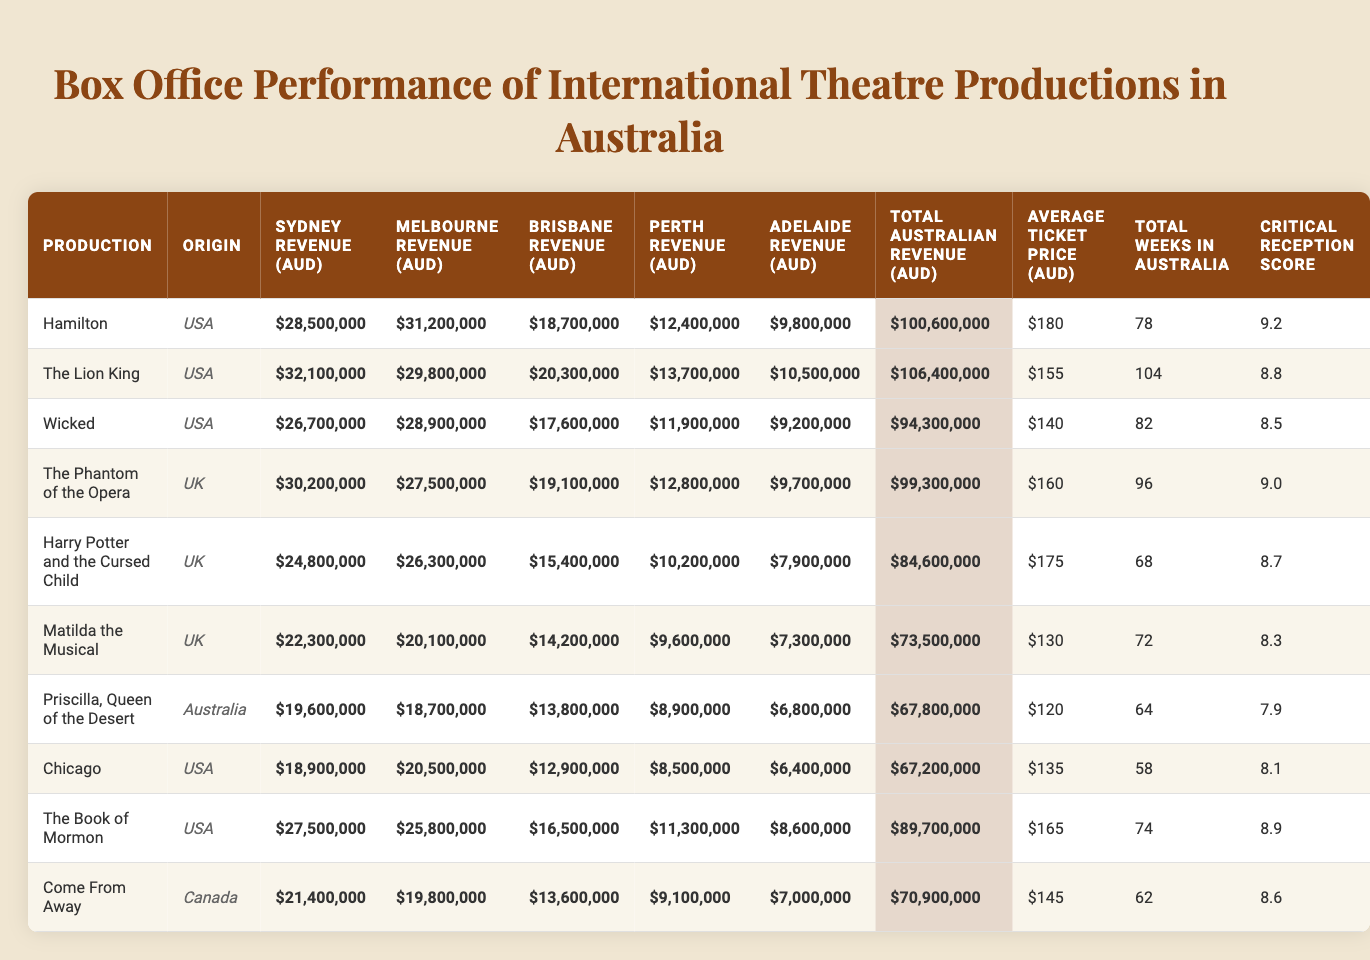What is the total revenue from the production "Hamilton" in Australia? The table shows the total Australian revenue for "Hamilton" as $100,600,000, which is provided in the "Total Australian Revenue (AUD)" column.
Answer: $100,600,000 Which production has the highest Sydney revenue? Looking at the "Sydney Revenue (AUD)" column, "The Lion King" has the highest revenue at $32,100,000.
Answer: The Lion King What is the average ticket price for "Matilda the Musical"? From the "Average Ticket Price (AUD)" column, the ticket price for "Matilda the Musical" is $130.
Answer: $130 How much more revenue did "Wicked" generate in Melbourne than in Adelaide? Calculating the difference, "Wicked" earned $28,900,000 in Melbourne and $9,200,000 in Adelaide. The difference is $28,900,000 - $9,200,000 = $19,700,000.
Answer: $19,700,000 Which production had the lowest Brisbane revenue? The "Brisbane Revenue (AUD)" column shows that "Priscilla, Queen of the Desert" had the lowest revenue at $13,800,000.
Answer: Priscilla, Queen of the Desert What is the total revenue for all productions in Perth? Adding all the values in the "Perth Revenue (AUD)" column: 12,400,000 + 13,700,000 + 11,900,000 + 12,800,000 + 10,200,000 + 9,600,000 + 8,900,000 + 8,500,000 + 11,300,000 + 9,100,000 gives a total of $110,000,000.
Answer: $110,000,000 Did "Come From Away" earn more in Brisbane or Adelaide? "Come From Away" earned $13,600,000 in Brisbane and $7,000,000 in Adelaide. Since $13,600,000 > $7,000,000, it earned more in Brisbane.
Answer: Yes What percentage of the total Australian revenue did "The Phantom of the Opera" contribute? "The Phantom of the Opera" generated $99,300,000 of the total $846,000,000. The percentage is calculated as ($99,300,000 / $846,000,000) * 100 = approximately 11.7%.
Answer: 11.7% Which production had the highest critical reception and what was the score? The production with the highest critical reception score is "Hamilton," which received a score of 9.2, found in the "Critical Reception Score" column.
Answer: Hamilton, 9.2 What was the total revenue generated by all productions from Sydney? To find this, sum the values from the "Sydney Revenue (AUD)" column: 28,500,000 + 32,100,000 + 26,700,000 + 30,200,000 + 24,800,000 + 22,300,000 + 19,600,000 + 18,900,000 + 27,500,000 + 21,400,000, resulting in $264,800,000.
Answer: $264,800,000 